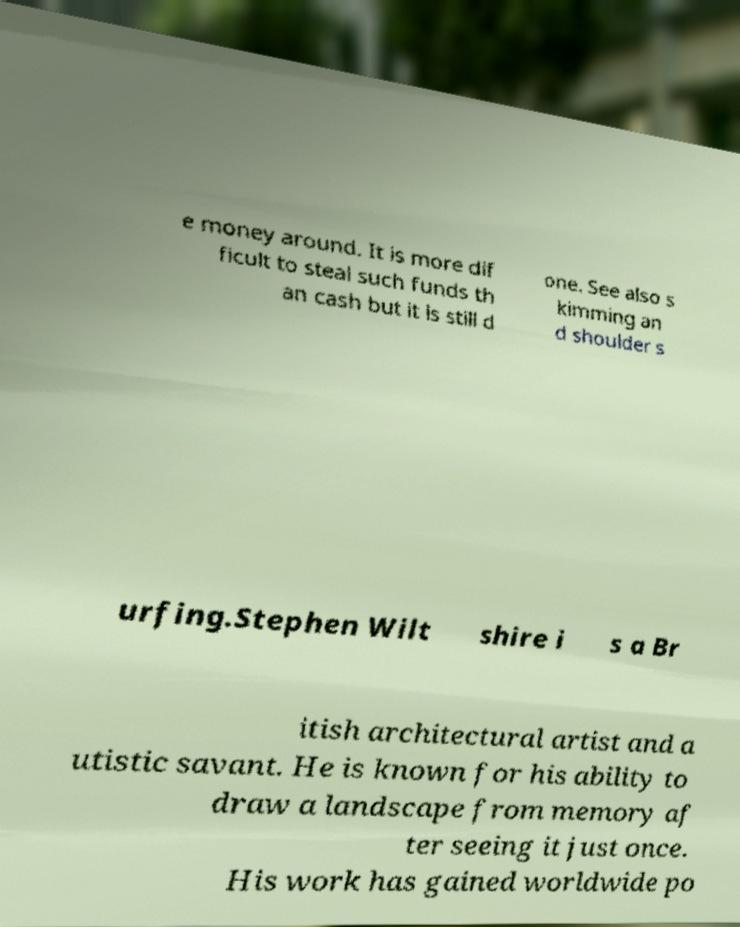Can you accurately transcribe the text from the provided image for me? e money around. It is more dif ficult to steal such funds th an cash but it is still d one. See also s kimming an d shoulder s urfing.Stephen Wilt shire i s a Br itish architectural artist and a utistic savant. He is known for his ability to draw a landscape from memory af ter seeing it just once. His work has gained worldwide po 